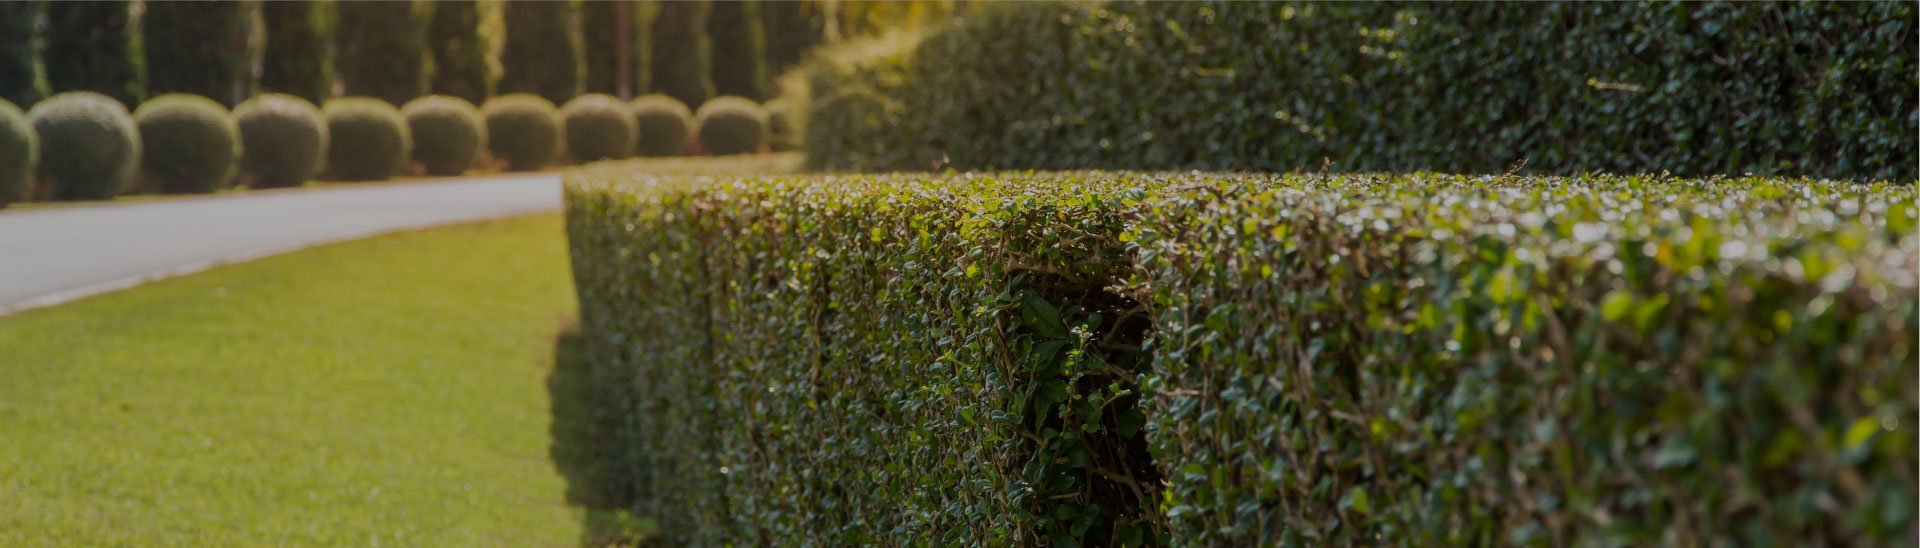What time of year do you think this image was taken, considering the condition of the plants? Given the lush greenery and the healthy appearance of the plants, the image was likely taken during the late spring or early summer. This is when plant growth is most vigorous, and the weather conditions promote lush, green lawns and well-maintained hedges. 